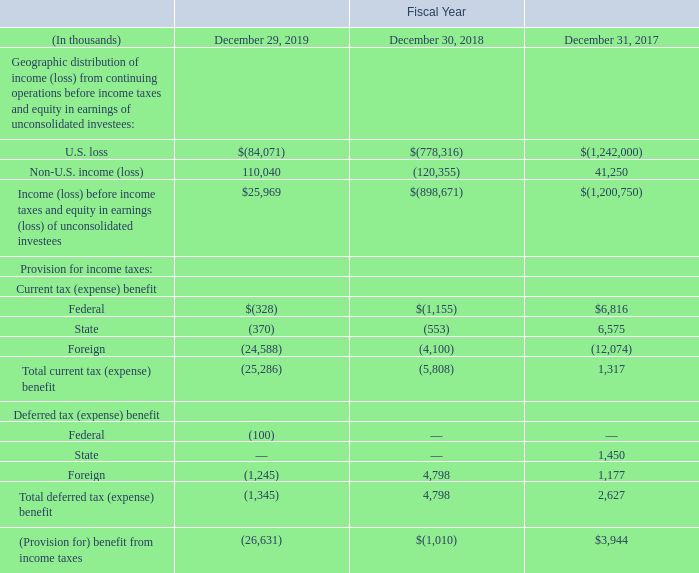Note 13. INCOME TAXES
In the year ended December 29, 2019, our income tax provision of $26.6 million on a profit before income taxes and equity in earnings (losses) of unconsolidated investees of $26.0 million was primarily due to tax expense in foreign jurisdictions that were profitable. In the year ended December 30, 2018, our income tax provision of $1.0 million on a loss before income taxes and equity in earnings of unconsolidated investees of $898.7 million was primarily due to tax expense in foreign jurisdictions that were profitable, offset by tax benefit related to release of valuation allowance in a foreign jurisdiction, and by a release of tax reserves due to lapse of statutes of limitation.
The geographic distribution of income (loss) from continuing operations before income taxes and equity earnings (losses) of unconsolidated investees and the components of provision for income taxes are summarized below:
In which years was the income taxes recorded for? 2019, 2018, 2017. What was the income tax provision on equity in earnings (losses) of unconsolidated investees in 2019? $26.0 million. What was the state deferred tax (expense) benefit in 2017?
Answer scale should be: thousand. 1,450. Which year was the total current tax benefit the highest? 1,317 > (5,808) > (25,286)
Answer: 2017. What was the change in federal deferred tax  benefit from 2018 to 2019?
Answer scale should be: thousand. -100 - 0 
Answer: -100. What was the percentage change in Total deferred tax benefit  from 2017 to 2018?
Answer scale should be: percent. (4,798- 2,627)/ 2,627  
Answer: 82.64. 